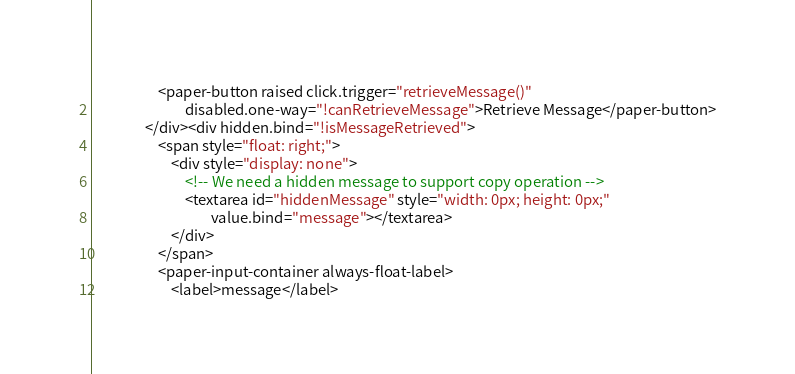<code> <loc_0><loc_0><loc_500><loc_500><_HTML_>                    <paper-button raised click.trigger="retrieveMessage()"
                    	    disabled.one-way="!canRetrieveMessage">Retrieve Message</paper-button>
                </div><div hidden.bind="!isMessageRetrieved">
                    <span style="float: right;">
                        <div style="display: none">
                            <!-- We need a hidden message to support copy operation -->
                            <textarea id="hiddenMessage" style="width: 0px; height: 0px;"
                                    value.bind="message"></textarea>
                        </div>
                    </span>
                    <paper-input-container always-float-label>
                        <label>message</label></code> 